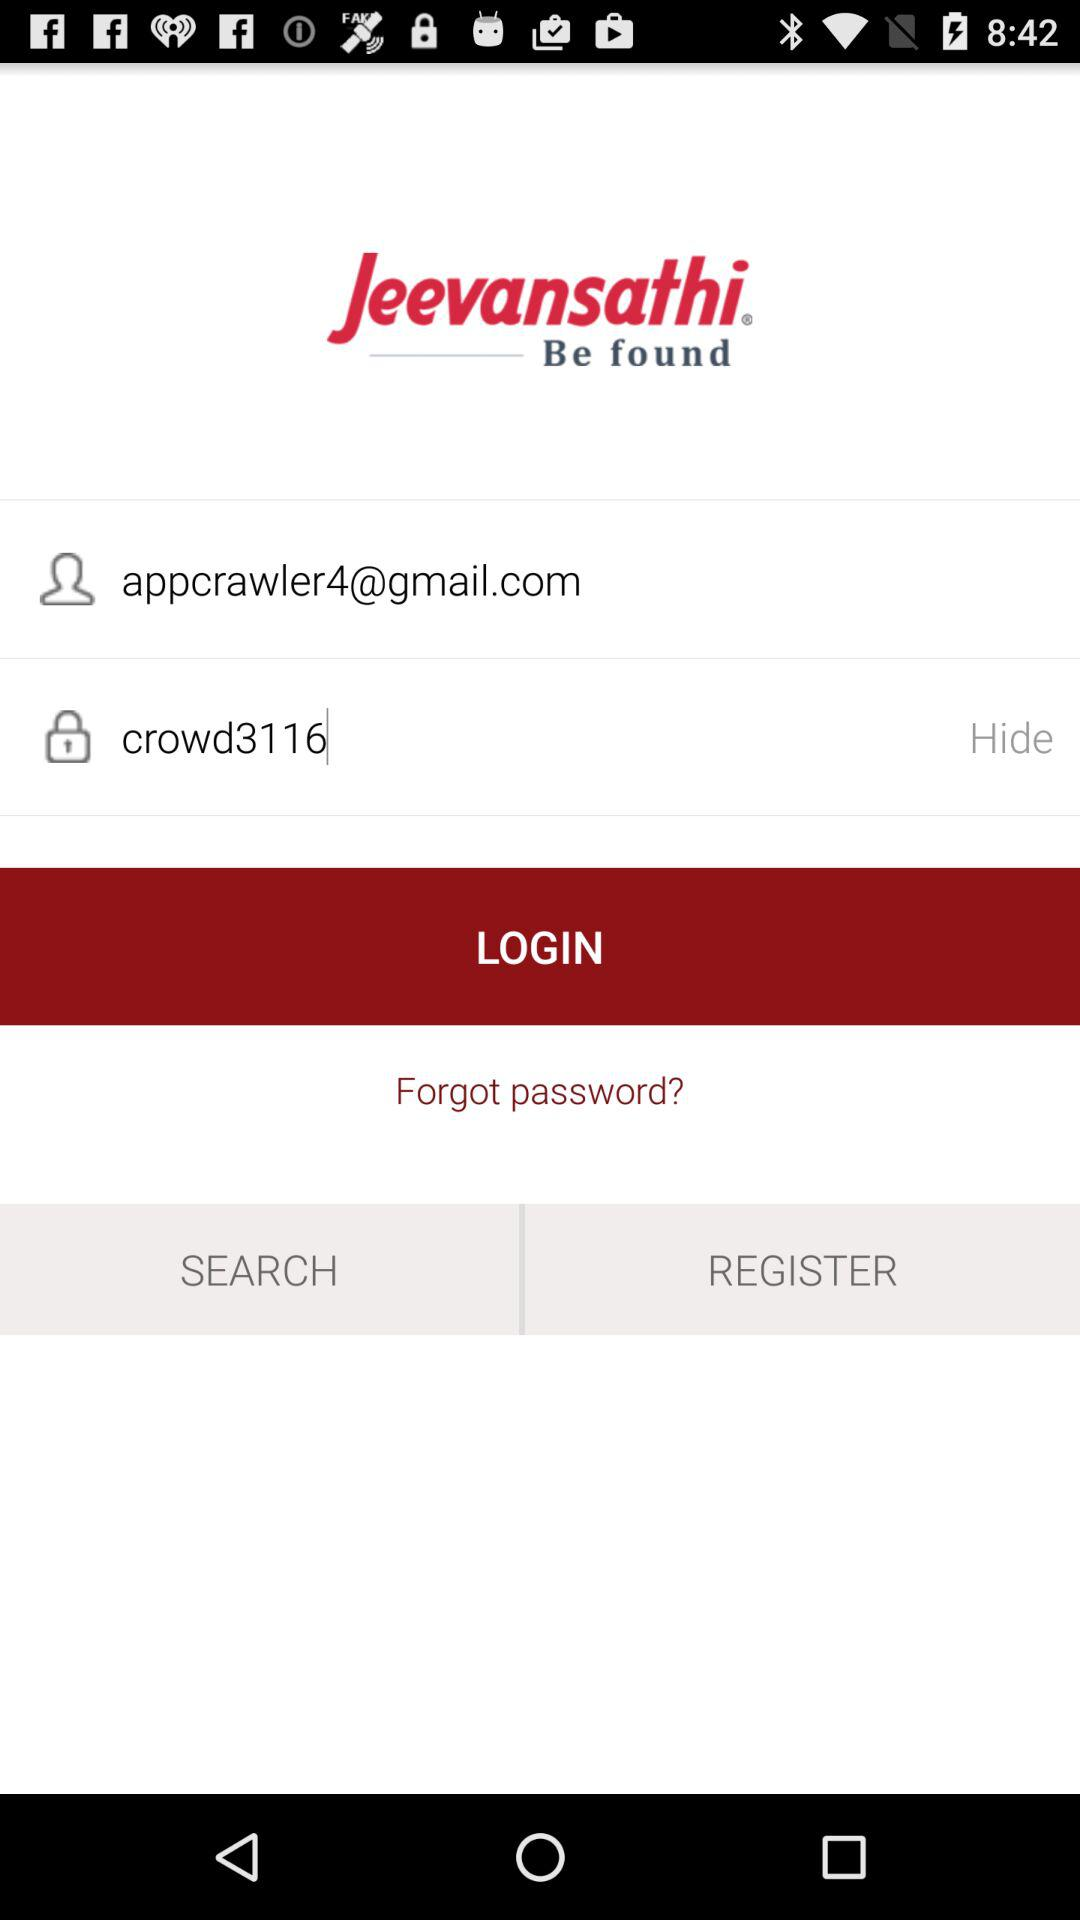How many fields are required to login?
Answer the question using a single word or phrase. 2 